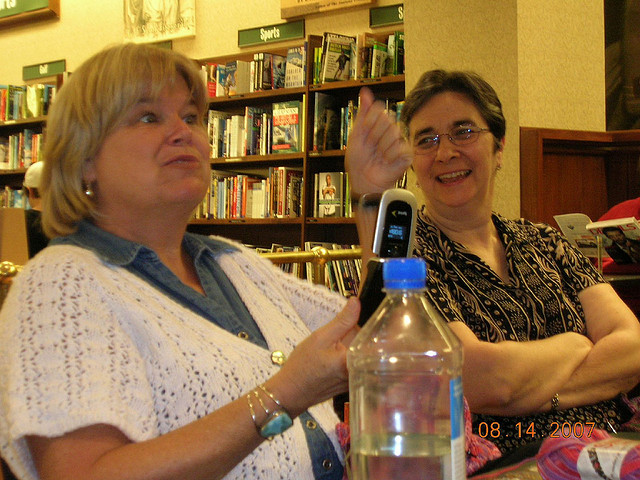Please transcribe the text information in this image. S 2007 14 08 